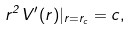<formula> <loc_0><loc_0><loc_500><loc_500>r ^ { 2 } V ^ { \prime } ( r ) | _ { r = r _ { c } } = c ,</formula> 